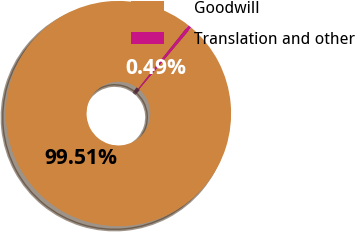<chart> <loc_0><loc_0><loc_500><loc_500><pie_chart><fcel>Goodwill<fcel>Translation and other<nl><fcel>99.51%<fcel>0.49%<nl></chart> 